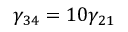<formula> <loc_0><loc_0><loc_500><loc_500>\gamma _ { 3 4 } = 1 0 \gamma _ { 2 1 }</formula> 